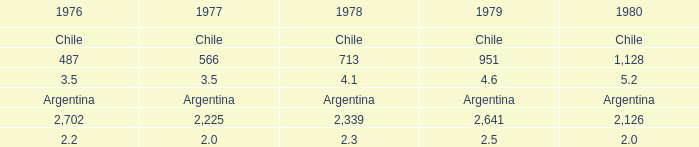1? 3.5. 